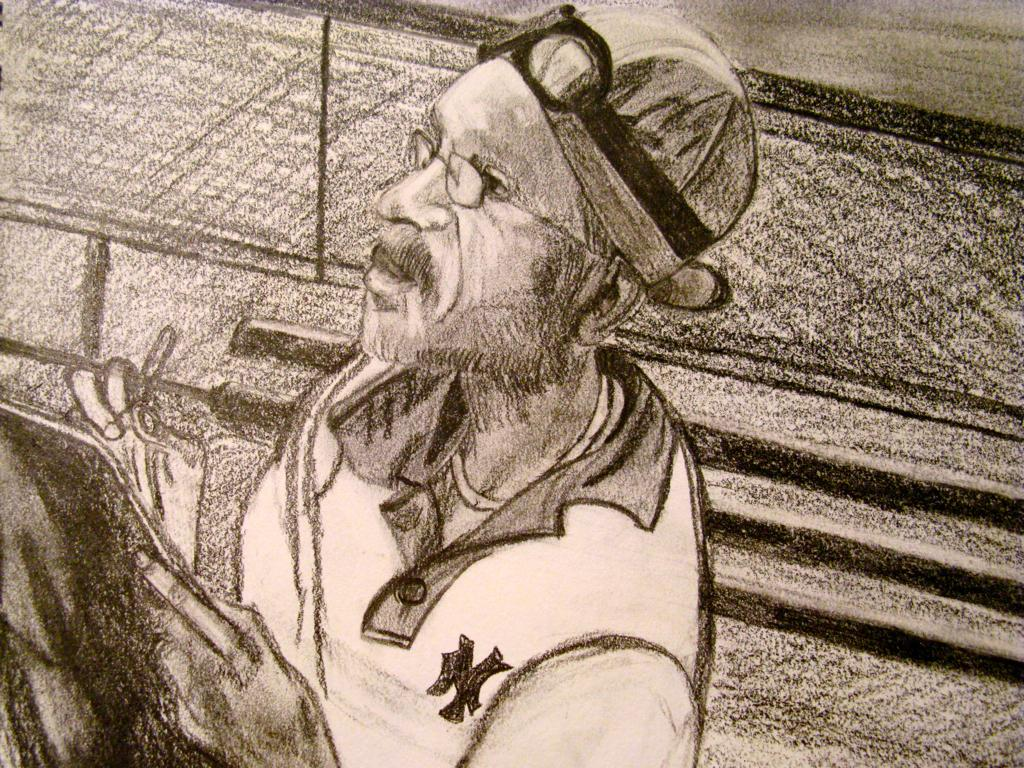What type of artwork is depicted in the image? The image is a sketch. Can you describe the subject of the sketch? There is a person in the image. What is the person doing in the sketch? The person is holding an object. What date is circled on the calendar in the image? There is no calendar present in the image, as it is a sketch of a person holding an object. 